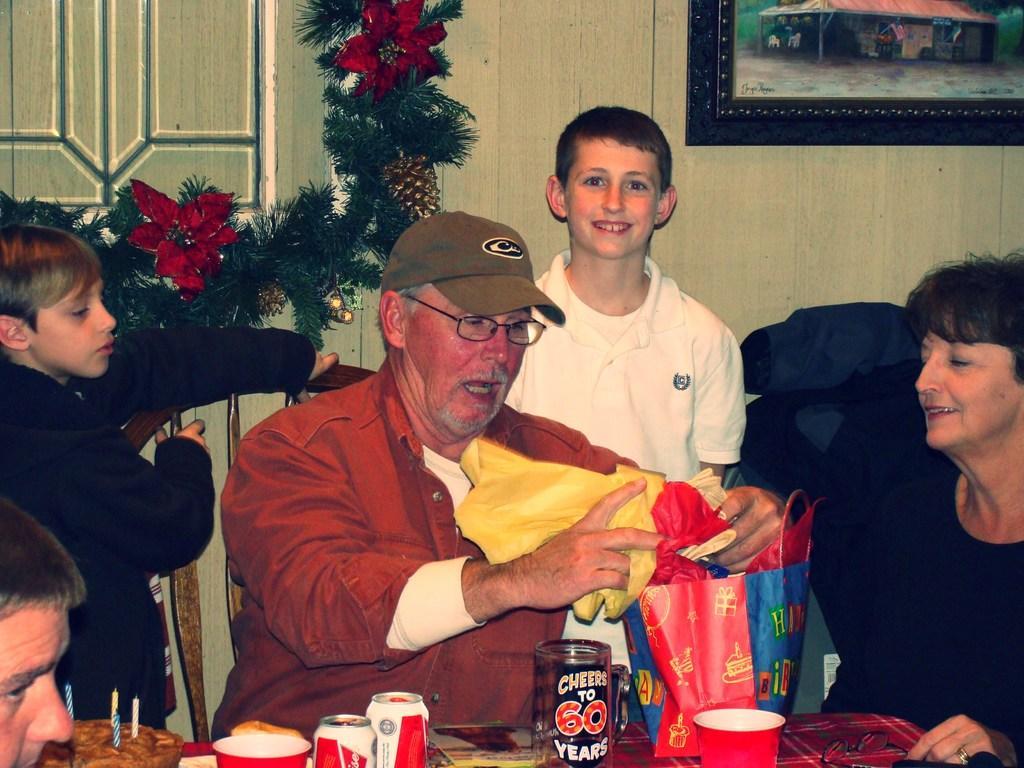Can you describe this image briefly? In this image there is a table, on that table there are bottles, glasses, cake and a bag, around the table there are three persons sitting on chairs, behind them there are two boys standing, in the background there is a Christmas tree and a wall, for that wall there is a photo frame. 